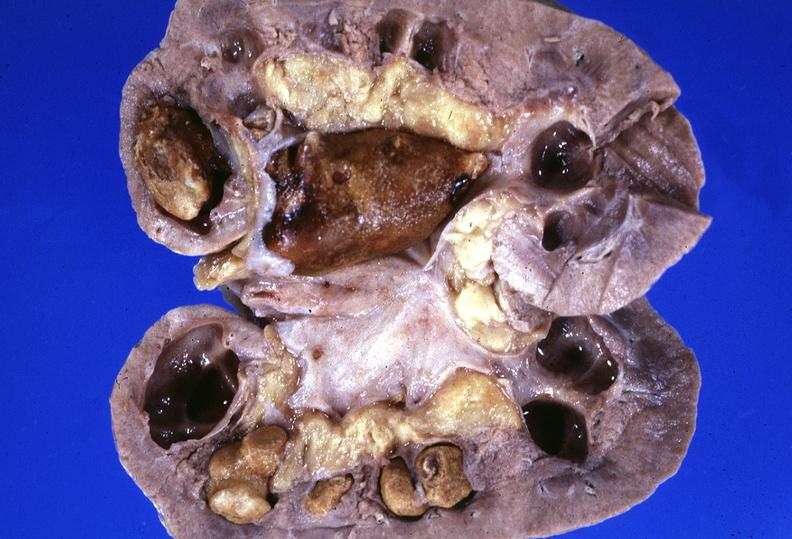what does this image show?
Answer the question using a single word or phrase. Kidney 